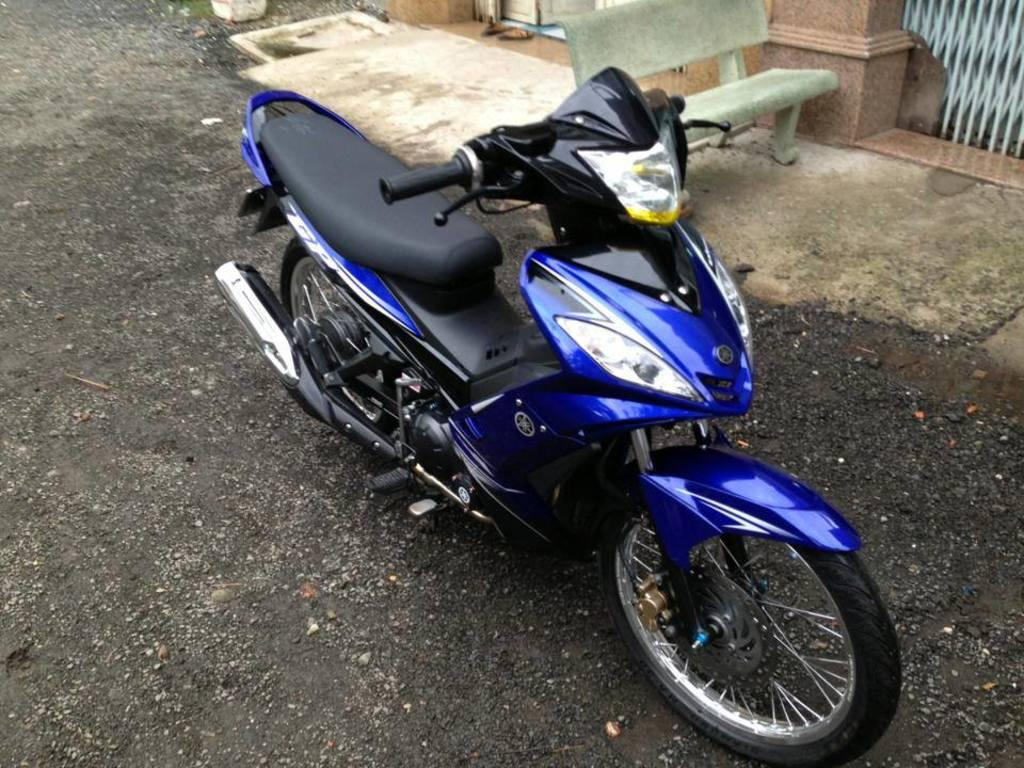What color is the motorbike in the image? The motorbike is blue and black in color. Where is the motorbike located in the image? The motorbike is on the road in the image. What other objects can be seen in the image besides the motorbike? There is a bench and a gate present in the image. What type of body of water is visible in the image? There is no body of water present in the image; it features a motorbike on the road, a bench, and a gate. What belief system is being practiced by the people in the image? There are no people visible in the image, and therefore no belief system can be determined. 